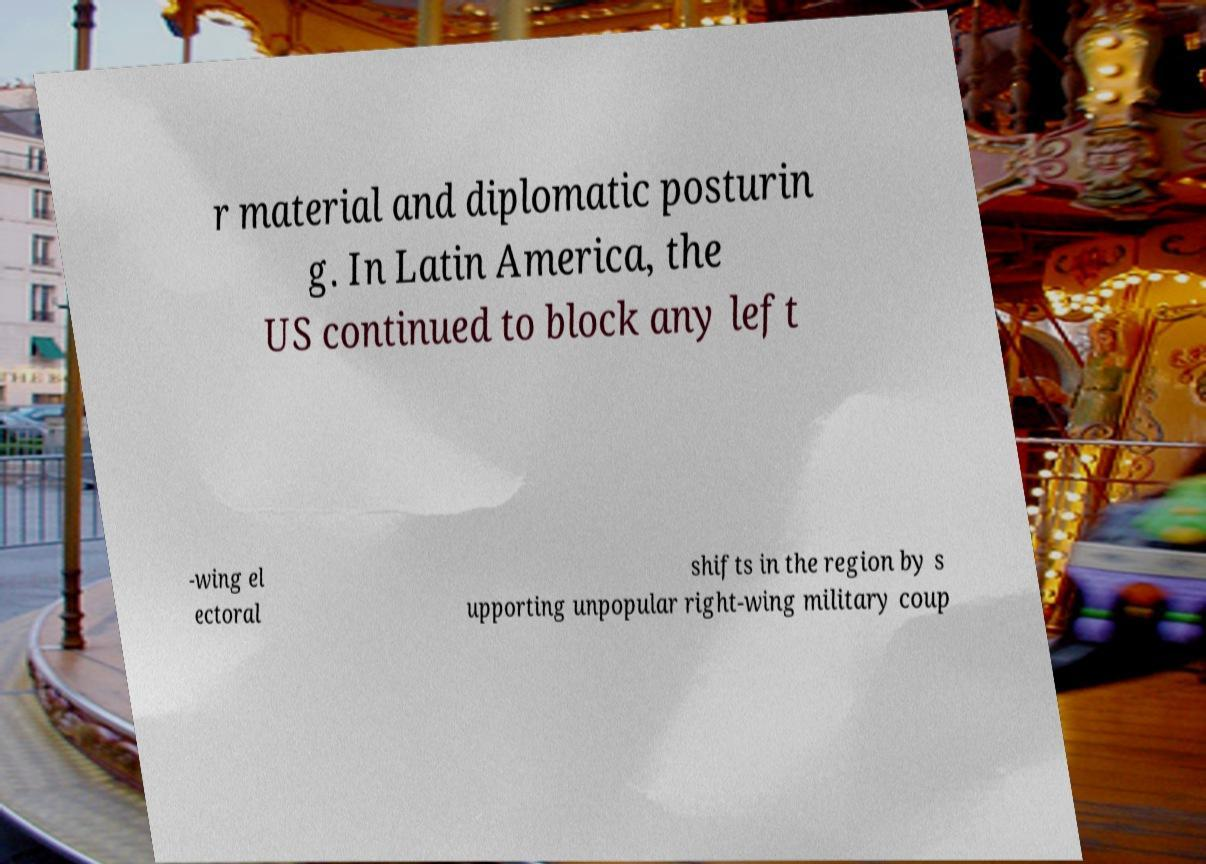Please read and relay the text visible in this image. What does it say? r material and diplomatic posturin g. In Latin America, the US continued to block any left -wing el ectoral shifts in the region by s upporting unpopular right-wing military coup 